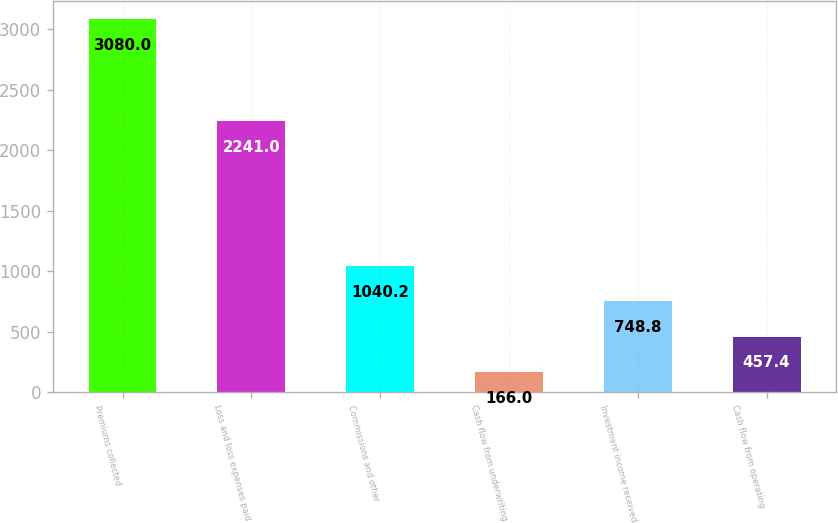Convert chart to OTSL. <chart><loc_0><loc_0><loc_500><loc_500><bar_chart><fcel>Premiums collected<fcel>Loss and loss expenses paid<fcel>Commissions and other<fcel>Cash flow from underwriting<fcel>Investment income received<fcel>Cash flow from operating<nl><fcel>3080<fcel>2241<fcel>1040.2<fcel>166<fcel>748.8<fcel>457.4<nl></chart> 